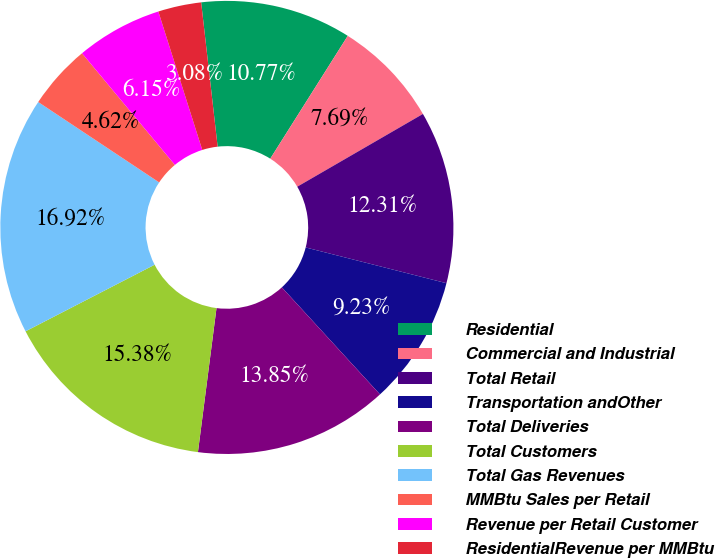Convert chart to OTSL. <chart><loc_0><loc_0><loc_500><loc_500><pie_chart><fcel>Residential<fcel>Commercial and Industrial<fcel>Total Retail<fcel>Transportation andOther<fcel>Total Deliveries<fcel>Total Customers<fcel>Total Gas Revenues<fcel>MMBtu Sales per Retail<fcel>Revenue per Retail Customer<fcel>ResidentialRevenue per MMBtu<nl><fcel>10.77%<fcel>7.69%<fcel>12.31%<fcel>9.23%<fcel>13.85%<fcel>15.38%<fcel>16.92%<fcel>4.62%<fcel>6.15%<fcel>3.08%<nl></chart> 